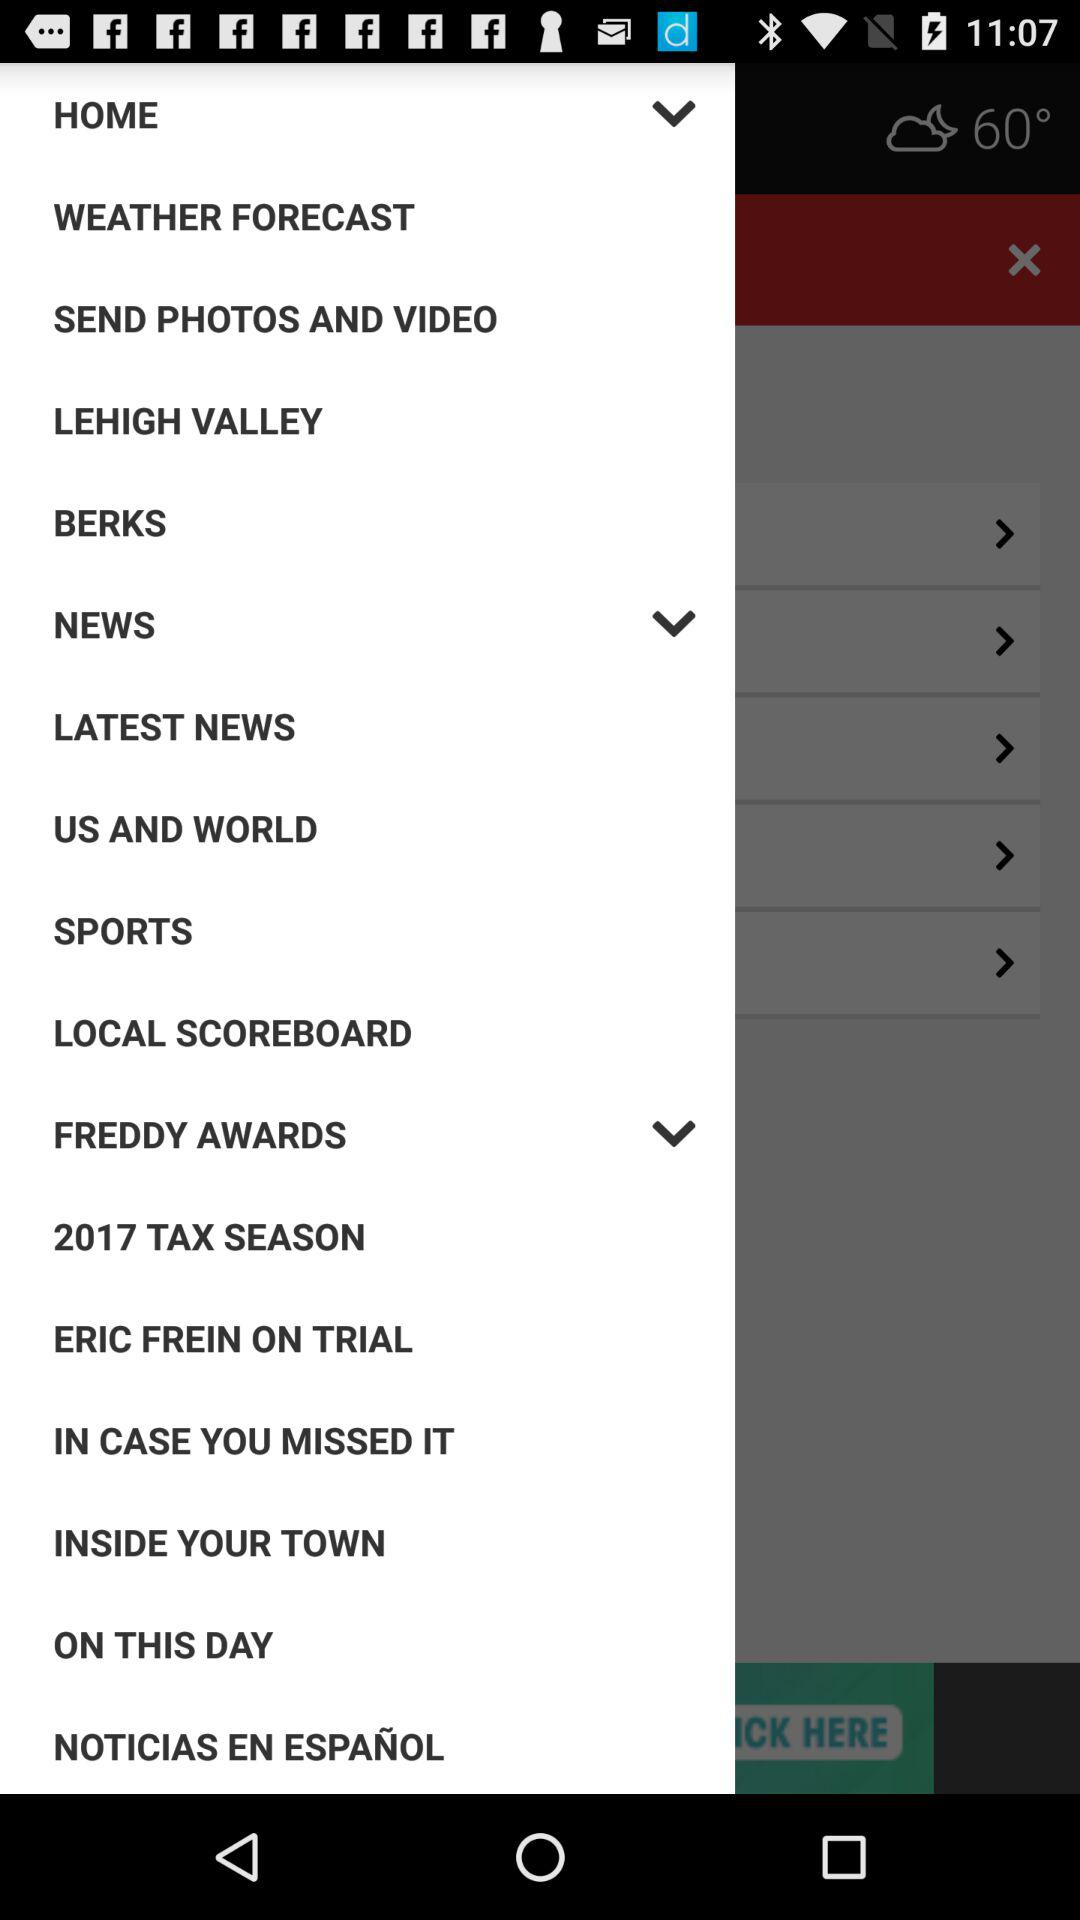What is the mentioned year for the tax season? The mentioned year is 2017. 